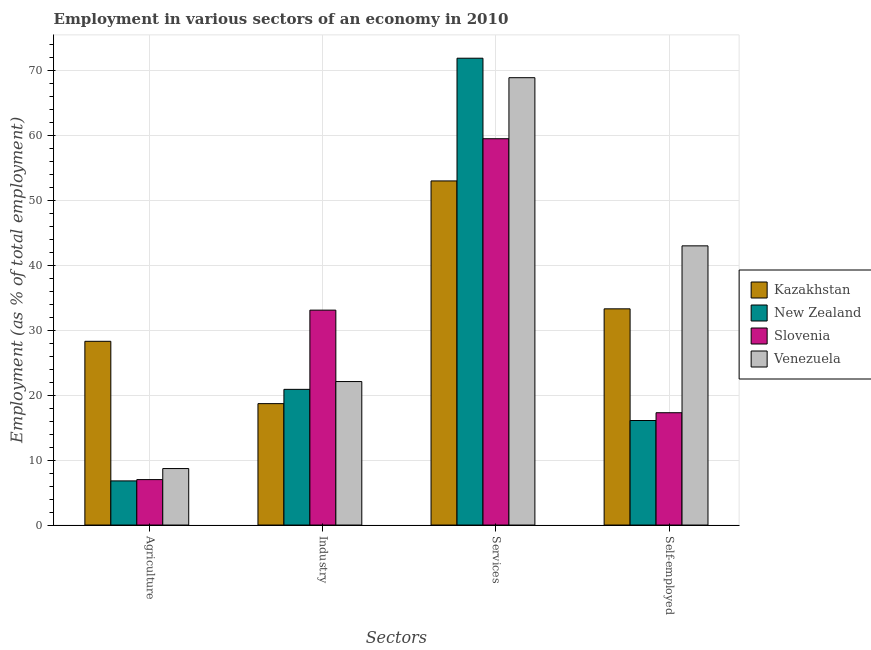How many different coloured bars are there?
Provide a succinct answer. 4. How many groups of bars are there?
Ensure brevity in your answer.  4. Are the number of bars per tick equal to the number of legend labels?
Ensure brevity in your answer.  Yes. Are the number of bars on each tick of the X-axis equal?
Offer a very short reply. Yes. How many bars are there on the 3rd tick from the left?
Ensure brevity in your answer.  4. What is the label of the 4th group of bars from the left?
Your response must be concise. Self-employed. What is the percentage of workers in agriculture in Kazakhstan?
Make the answer very short. 28.3. Across all countries, what is the maximum percentage of workers in agriculture?
Your response must be concise. 28.3. Across all countries, what is the minimum percentage of workers in agriculture?
Ensure brevity in your answer.  6.8. In which country was the percentage of workers in industry maximum?
Provide a short and direct response. Slovenia. In which country was the percentage of workers in services minimum?
Give a very brief answer. Kazakhstan. What is the total percentage of self employed workers in the graph?
Offer a very short reply. 109.7. What is the difference between the percentage of workers in services in Kazakhstan and that in Venezuela?
Keep it short and to the point. -15.9. What is the difference between the percentage of workers in industry in New Zealand and the percentage of self employed workers in Kazakhstan?
Your answer should be compact. -12.4. What is the average percentage of self employed workers per country?
Your answer should be compact. 27.42. What is the difference between the percentage of workers in services and percentage of self employed workers in Kazakhstan?
Your response must be concise. 19.7. What is the ratio of the percentage of workers in agriculture in New Zealand to that in Slovenia?
Make the answer very short. 0.97. Is the percentage of workers in industry in Kazakhstan less than that in Venezuela?
Your answer should be very brief. Yes. Is the difference between the percentage of workers in industry in Venezuela and New Zealand greater than the difference between the percentage of workers in services in Venezuela and New Zealand?
Offer a terse response. Yes. What is the difference between the highest and the second highest percentage of workers in agriculture?
Offer a very short reply. 19.6. What is the difference between the highest and the lowest percentage of self employed workers?
Make the answer very short. 26.9. In how many countries, is the percentage of workers in agriculture greater than the average percentage of workers in agriculture taken over all countries?
Provide a succinct answer. 1. Is it the case that in every country, the sum of the percentage of workers in agriculture and percentage of workers in services is greater than the sum of percentage of self employed workers and percentage of workers in industry?
Your response must be concise. No. What does the 3rd bar from the left in Industry represents?
Keep it short and to the point. Slovenia. What does the 3rd bar from the right in Self-employed represents?
Your response must be concise. New Zealand. How many countries are there in the graph?
Your response must be concise. 4. Does the graph contain grids?
Your answer should be compact. Yes. Where does the legend appear in the graph?
Provide a succinct answer. Center right. How many legend labels are there?
Offer a very short reply. 4. What is the title of the graph?
Your response must be concise. Employment in various sectors of an economy in 2010. Does "Liechtenstein" appear as one of the legend labels in the graph?
Offer a very short reply. No. What is the label or title of the X-axis?
Your response must be concise. Sectors. What is the label or title of the Y-axis?
Keep it short and to the point. Employment (as % of total employment). What is the Employment (as % of total employment) of Kazakhstan in Agriculture?
Provide a succinct answer. 28.3. What is the Employment (as % of total employment) in New Zealand in Agriculture?
Ensure brevity in your answer.  6.8. What is the Employment (as % of total employment) in Venezuela in Agriculture?
Offer a terse response. 8.7. What is the Employment (as % of total employment) of Kazakhstan in Industry?
Your response must be concise. 18.7. What is the Employment (as % of total employment) of New Zealand in Industry?
Your response must be concise. 20.9. What is the Employment (as % of total employment) in Slovenia in Industry?
Keep it short and to the point. 33.1. What is the Employment (as % of total employment) in Venezuela in Industry?
Make the answer very short. 22.1. What is the Employment (as % of total employment) in New Zealand in Services?
Your response must be concise. 71.9. What is the Employment (as % of total employment) in Slovenia in Services?
Keep it short and to the point. 59.5. What is the Employment (as % of total employment) in Venezuela in Services?
Offer a terse response. 68.9. What is the Employment (as % of total employment) in Kazakhstan in Self-employed?
Make the answer very short. 33.3. What is the Employment (as % of total employment) in New Zealand in Self-employed?
Give a very brief answer. 16.1. What is the Employment (as % of total employment) of Slovenia in Self-employed?
Ensure brevity in your answer.  17.3. What is the Employment (as % of total employment) in Venezuela in Self-employed?
Your answer should be compact. 43. Across all Sectors, what is the maximum Employment (as % of total employment) in New Zealand?
Provide a short and direct response. 71.9. Across all Sectors, what is the maximum Employment (as % of total employment) of Slovenia?
Your answer should be very brief. 59.5. Across all Sectors, what is the maximum Employment (as % of total employment) of Venezuela?
Provide a short and direct response. 68.9. Across all Sectors, what is the minimum Employment (as % of total employment) of Kazakhstan?
Your answer should be very brief. 18.7. Across all Sectors, what is the minimum Employment (as % of total employment) of New Zealand?
Provide a short and direct response. 6.8. Across all Sectors, what is the minimum Employment (as % of total employment) of Venezuela?
Your answer should be very brief. 8.7. What is the total Employment (as % of total employment) in Kazakhstan in the graph?
Provide a succinct answer. 133.3. What is the total Employment (as % of total employment) of New Zealand in the graph?
Provide a short and direct response. 115.7. What is the total Employment (as % of total employment) of Slovenia in the graph?
Your answer should be compact. 116.9. What is the total Employment (as % of total employment) in Venezuela in the graph?
Ensure brevity in your answer.  142.7. What is the difference between the Employment (as % of total employment) in New Zealand in Agriculture and that in Industry?
Offer a terse response. -14.1. What is the difference between the Employment (as % of total employment) of Slovenia in Agriculture and that in Industry?
Your answer should be compact. -26.1. What is the difference between the Employment (as % of total employment) in Kazakhstan in Agriculture and that in Services?
Ensure brevity in your answer.  -24.7. What is the difference between the Employment (as % of total employment) in New Zealand in Agriculture and that in Services?
Offer a very short reply. -65.1. What is the difference between the Employment (as % of total employment) in Slovenia in Agriculture and that in Services?
Make the answer very short. -52.5. What is the difference between the Employment (as % of total employment) in Venezuela in Agriculture and that in Services?
Offer a terse response. -60.2. What is the difference between the Employment (as % of total employment) of Slovenia in Agriculture and that in Self-employed?
Provide a succinct answer. -10.3. What is the difference between the Employment (as % of total employment) in Venezuela in Agriculture and that in Self-employed?
Provide a short and direct response. -34.3. What is the difference between the Employment (as % of total employment) in Kazakhstan in Industry and that in Services?
Provide a succinct answer. -34.3. What is the difference between the Employment (as % of total employment) in New Zealand in Industry and that in Services?
Make the answer very short. -51. What is the difference between the Employment (as % of total employment) of Slovenia in Industry and that in Services?
Make the answer very short. -26.4. What is the difference between the Employment (as % of total employment) in Venezuela in Industry and that in Services?
Your answer should be very brief. -46.8. What is the difference between the Employment (as % of total employment) in Kazakhstan in Industry and that in Self-employed?
Make the answer very short. -14.6. What is the difference between the Employment (as % of total employment) in New Zealand in Industry and that in Self-employed?
Give a very brief answer. 4.8. What is the difference between the Employment (as % of total employment) in Slovenia in Industry and that in Self-employed?
Keep it short and to the point. 15.8. What is the difference between the Employment (as % of total employment) in Venezuela in Industry and that in Self-employed?
Keep it short and to the point. -20.9. What is the difference between the Employment (as % of total employment) in Kazakhstan in Services and that in Self-employed?
Give a very brief answer. 19.7. What is the difference between the Employment (as % of total employment) of New Zealand in Services and that in Self-employed?
Keep it short and to the point. 55.8. What is the difference between the Employment (as % of total employment) of Slovenia in Services and that in Self-employed?
Give a very brief answer. 42.2. What is the difference between the Employment (as % of total employment) in Venezuela in Services and that in Self-employed?
Give a very brief answer. 25.9. What is the difference between the Employment (as % of total employment) in Kazakhstan in Agriculture and the Employment (as % of total employment) in Slovenia in Industry?
Offer a terse response. -4.8. What is the difference between the Employment (as % of total employment) in Kazakhstan in Agriculture and the Employment (as % of total employment) in Venezuela in Industry?
Provide a short and direct response. 6.2. What is the difference between the Employment (as % of total employment) of New Zealand in Agriculture and the Employment (as % of total employment) of Slovenia in Industry?
Your answer should be compact. -26.3. What is the difference between the Employment (as % of total employment) in New Zealand in Agriculture and the Employment (as % of total employment) in Venezuela in Industry?
Your answer should be compact. -15.3. What is the difference between the Employment (as % of total employment) in Slovenia in Agriculture and the Employment (as % of total employment) in Venezuela in Industry?
Keep it short and to the point. -15.1. What is the difference between the Employment (as % of total employment) of Kazakhstan in Agriculture and the Employment (as % of total employment) of New Zealand in Services?
Your answer should be very brief. -43.6. What is the difference between the Employment (as % of total employment) in Kazakhstan in Agriculture and the Employment (as % of total employment) in Slovenia in Services?
Offer a very short reply. -31.2. What is the difference between the Employment (as % of total employment) of Kazakhstan in Agriculture and the Employment (as % of total employment) of Venezuela in Services?
Your response must be concise. -40.6. What is the difference between the Employment (as % of total employment) of New Zealand in Agriculture and the Employment (as % of total employment) of Slovenia in Services?
Ensure brevity in your answer.  -52.7. What is the difference between the Employment (as % of total employment) of New Zealand in Agriculture and the Employment (as % of total employment) of Venezuela in Services?
Your response must be concise. -62.1. What is the difference between the Employment (as % of total employment) of Slovenia in Agriculture and the Employment (as % of total employment) of Venezuela in Services?
Give a very brief answer. -61.9. What is the difference between the Employment (as % of total employment) of Kazakhstan in Agriculture and the Employment (as % of total employment) of Slovenia in Self-employed?
Provide a short and direct response. 11. What is the difference between the Employment (as % of total employment) of Kazakhstan in Agriculture and the Employment (as % of total employment) of Venezuela in Self-employed?
Offer a very short reply. -14.7. What is the difference between the Employment (as % of total employment) in New Zealand in Agriculture and the Employment (as % of total employment) in Venezuela in Self-employed?
Keep it short and to the point. -36.2. What is the difference between the Employment (as % of total employment) of Slovenia in Agriculture and the Employment (as % of total employment) of Venezuela in Self-employed?
Your response must be concise. -36. What is the difference between the Employment (as % of total employment) in Kazakhstan in Industry and the Employment (as % of total employment) in New Zealand in Services?
Your answer should be compact. -53.2. What is the difference between the Employment (as % of total employment) in Kazakhstan in Industry and the Employment (as % of total employment) in Slovenia in Services?
Make the answer very short. -40.8. What is the difference between the Employment (as % of total employment) of Kazakhstan in Industry and the Employment (as % of total employment) of Venezuela in Services?
Your answer should be compact. -50.2. What is the difference between the Employment (as % of total employment) in New Zealand in Industry and the Employment (as % of total employment) in Slovenia in Services?
Keep it short and to the point. -38.6. What is the difference between the Employment (as % of total employment) in New Zealand in Industry and the Employment (as % of total employment) in Venezuela in Services?
Give a very brief answer. -48. What is the difference between the Employment (as % of total employment) in Slovenia in Industry and the Employment (as % of total employment) in Venezuela in Services?
Make the answer very short. -35.8. What is the difference between the Employment (as % of total employment) in Kazakhstan in Industry and the Employment (as % of total employment) in Venezuela in Self-employed?
Ensure brevity in your answer.  -24.3. What is the difference between the Employment (as % of total employment) in New Zealand in Industry and the Employment (as % of total employment) in Slovenia in Self-employed?
Ensure brevity in your answer.  3.6. What is the difference between the Employment (as % of total employment) of New Zealand in Industry and the Employment (as % of total employment) of Venezuela in Self-employed?
Make the answer very short. -22.1. What is the difference between the Employment (as % of total employment) in Kazakhstan in Services and the Employment (as % of total employment) in New Zealand in Self-employed?
Your answer should be very brief. 36.9. What is the difference between the Employment (as % of total employment) of Kazakhstan in Services and the Employment (as % of total employment) of Slovenia in Self-employed?
Offer a very short reply. 35.7. What is the difference between the Employment (as % of total employment) of New Zealand in Services and the Employment (as % of total employment) of Slovenia in Self-employed?
Give a very brief answer. 54.6. What is the difference between the Employment (as % of total employment) of New Zealand in Services and the Employment (as % of total employment) of Venezuela in Self-employed?
Offer a very short reply. 28.9. What is the average Employment (as % of total employment) in Kazakhstan per Sectors?
Make the answer very short. 33.33. What is the average Employment (as % of total employment) of New Zealand per Sectors?
Give a very brief answer. 28.93. What is the average Employment (as % of total employment) in Slovenia per Sectors?
Keep it short and to the point. 29.23. What is the average Employment (as % of total employment) of Venezuela per Sectors?
Offer a very short reply. 35.67. What is the difference between the Employment (as % of total employment) of Kazakhstan and Employment (as % of total employment) of New Zealand in Agriculture?
Your answer should be very brief. 21.5. What is the difference between the Employment (as % of total employment) in Kazakhstan and Employment (as % of total employment) in Slovenia in Agriculture?
Ensure brevity in your answer.  21.3. What is the difference between the Employment (as % of total employment) in Kazakhstan and Employment (as % of total employment) in Venezuela in Agriculture?
Your answer should be compact. 19.6. What is the difference between the Employment (as % of total employment) of New Zealand and Employment (as % of total employment) of Slovenia in Agriculture?
Ensure brevity in your answer.  -0.2. What is the difference between the Employment (as % of total employment) in Kazakhstan and Employment (as % of total employment) in New Zealand in Industry?
Offer a terse response. -2.2. What is the difference between the Employment (as % of total employment) in Kazakhstan and Employment (as % of total employment) in Slovenia in Industry?
Provide a short and direct response. -14.4. What is the difference between the Employment (as % of total employment) in Kazakhstan and Employment (as % of total employment) in Venezuela in Industry?
Give a very brief answer. -3.4. What is the difference between the Employment (as % of total employment) of New Zealand and Employment (as % of total employment) of Venezuela in Industry?
Your answer should be compact. -1.2. What is the difference between the Employment (as % of total employment) of Slovenia and Employment (as % of total employment) of Venezuela in Industry?
Ensure brevity in your answer.  11. What is the difference between the Employment (as % of total employment) of Kazakhstan and Employment (as % of total employment) of New Zealand in Services?
Your answer should be very brief. -18.9. What is the difference between the Employment (as % of total employment) in Kazakhstan and Employment (as % of total employment) in Venezuela in Services?
Make the answer very short. -15.9. What is the difference between the Employment (as % of total employment) in Kazakhstan and Employment (as % of total employment) in New Zealand in Self-employed?
Provide a succinct answer. 17.2. What is the difference between the Employment (as % of total employment) of Kazakhstan and Employment (as % of total employment) of Venezuela in Self-employed?
Your answer should be compact. -9.7. What is the difference between the Employment (as % of total employment) in New Zealand and Employment (as % of total employment) in Slovenia in Self-employed?
Your answer should be compact. -1.2. What is the difference between the Employment (as % of total employment) of New Zealand and Employment (as % of total employment) of Venezuela in Self-employed?
Provide a succinct answer. -26.9. What is the difference between the Employment (as % of total employment) of Slovenia and Employment (as % of total employment) of Venezuela in Self-employed?
Provide a succinct answer. -25.7. What is the ratio of the Employment (as % of total employment) in Kazakhstan in Agriculture to that in Industry?
Ensure brevity in your answer.  1.51. What is the ratio of the Employment (as % of total employment) in New Zealand in Agriculture to that in Industry?
Provide a short and direct response. 0.33. What is the ratio of the Employment (as % of total employment) in Slovenia in Agriculture to that in Industry?
Your answer should be very brief. 0.21. What is the ratio of the Employment (as % of total employment) in Venezuela in Agriculture to that in Industry?
Provide a short and direct response. 0.39. What is the ratio of the Employment (as % of total employment) in Kazakhstan in Agriculture to that in Services?
Provide a short and direct response. 0.53. What is the ratio of the Employment (as % of total employment) in New Zealand in Agriculture to that in Services?
Make the answer very short. 0.09. What is the ratio of the Employment (as % of total employment) in Slovenia in Agriculture to that in Services?
Your answer should be compact. 0.12. What is the ratio of the Employment (as % of total employment) in Venezuela in Agriculture to that in Services?
Keep it short and to the point. 0.13. What is the ratio of the Employment (as % of total employment) in Kazakhstan in Agriculture to that in Self-employed?
Your answer should be very brief. 0.85. What is the ratio of the Employment (as % of total employment) in New Zealand in Agriculture to that in Self-employed?
Your response must be concise. 0.42. What is the ratio of the Employment (as % of total employment) in Slovenia in Agriculture to that in Self-employed?
Your answer should be compact. 0.4. What is the ratio of the Employment (as % of total employment) in Venezuela in Agriculture to that in Self-employed?
Ensure brevity in your answer.  0.2. What is the ratio of the Employment (as % of total employment) of Kazakhstan in Industry to that in Services?
Offer a very short reply. 0.35. What is the ratio of the Employment (as % of total employment) of New Zealand in Industry to that in Services?
Offer a terse response. 0.29. What is the ratio of the Employment (as % of total employment) in Slovenia in Industry to that in Services?
Your answer should be very brief. 0.56. What is the ratio of the Employment (as % of total employment) of Venezuela in Industry to that in Services?
Offer a very short reply. 0.32. What is the ratio of the Employment (as % of total employment) of Kazakhstan in Industry to that in Self-employed?
Your answer should be compact. 0.56. What is the ratio of the Employment (as % of total employment) in New Zealand in Industry to that in Self-employed?
Ensure brevity in your answer.  1.3. What is the ratio of the Employment (as % of total employment) of Slovenia in Industry to that in Self-employed?
Your answer should be very brief. 1.91. What is the ratio of the Employment (as % of total employment) in Venezuela in Industry to that in Self-employed?
Provide a short and direct response. 0.51. What is the ratio of the Employment (as % of total employment) in Kazakhstan in Services to that in Self-employed?
Provide a succinct answer. 1.59. What is the ratio of the Employment (as % of total employment) in New Zealand in Services to that in Self-employed?
Your answer should be very brief. 4.47. What is the ratio of the Employment (as % of total employment) of Slovenia in Services to that in Self-employed?
Offer a terse response. 3.44. What is the ratio of the Employment (as % of total employment) in Venezuela in Services to that in Self-employed?
Keep it short and to the point. 1.6. What is the difference between the highest and the second highest Employment (as % of total employment) of Kazakhstan?
Offer a very short reply. 19.7. What is the difference between the highest and the second highest Employment (as % of total employment) of Slovenia?
Provide a short and direct response. 26.4. What is the difference between the highest and the second highest Employment (as % of total employment) in Venezuela?
Your answer should be compact. 25.9. What is the difference between the highest and the lowest Employment (as % of total employment) of Kazakhstan?
Offer a terse response. 34.3. What is the difference between the highest and the lowest Employment (as % of total employment) of New Zealand?
Give a very brief answer. 65.1. What is the difference between the highest and the lowest Employment (as % of total employment) in Slovenia?
Give a very brief answer. 52.5. What is the difference between the highest and the lowest Employment (as % of total employment) of Venezuela?
Your response must be concise. 60.2. 